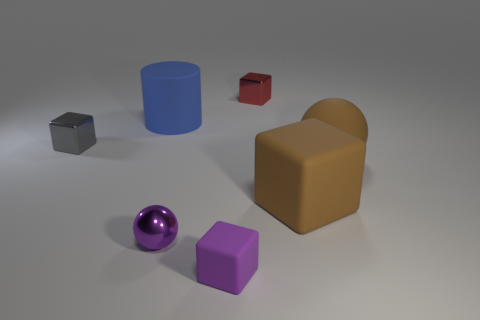How many objects are there in the image, and can you describe their colors? There are six objects in the image. Starting from the left, there's a small grey metallic cube, a shiny purple sphere, a medium-sized matte lilac cube, a large matte blue cylinder, a small red metallic cube, and a matte brown object with a unique curved shape. 